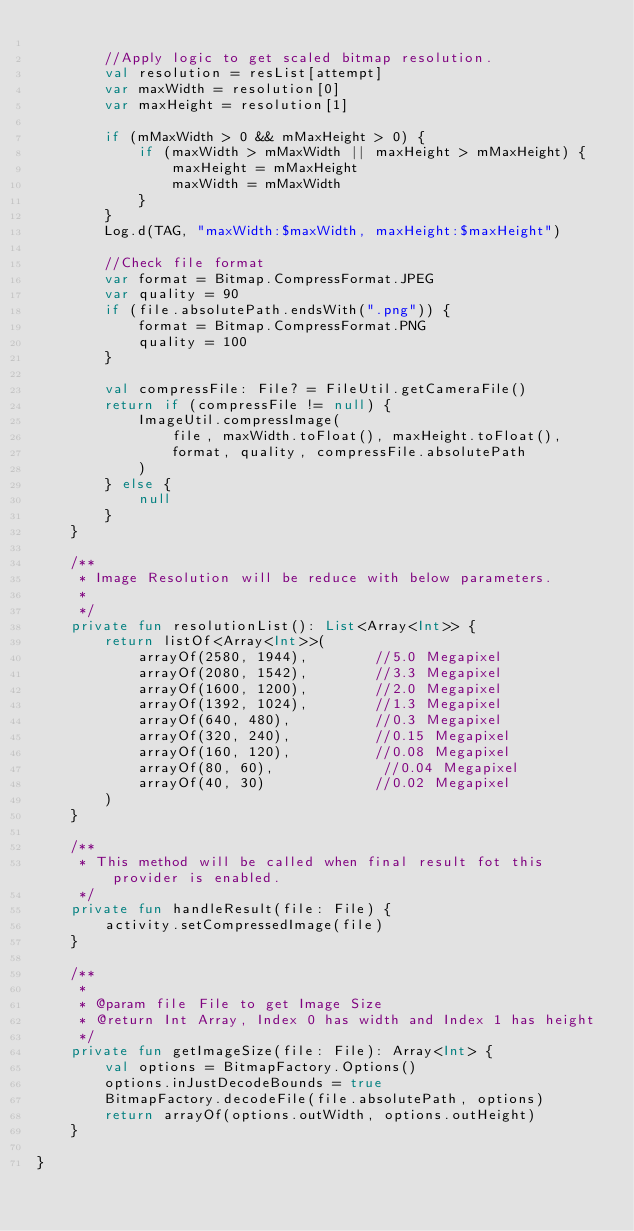<code> <loc_0><loc_0><loc_500><loc_500><_Kotlin_>
        //Apply logic to get scaled bitmap resolution.
        val resolution = resList[attempt]
        var maxWidth = resolution[0]
        var maxHeight = resolution[1]

        if (mMaxWidth > 0 && mMaxHeight > 0) {
            if (maxWidth > mMaxWidth || maxHeight > mMaxHeight) {
                maxHeight = mMaxHeight
                maxWidth = mMaxWidth
            }
        }
        Log.d(TAG, "maxWidth:$maxWidth, maxHeight:$maxHeight")

        //Check file format
        var format = Bitmap.CompressFormat.JPEG
        var quality = 90
        if (file.absolutePath.endsWith(".png")) {
            format = Bitmap.CompressFormat.PNG
            quality = 100
        }

        val compressFile: File? = FileUtil.getCameraFile()
        return if (compressFile != null) {
            ImageUtil.compressImage(
                file, maxWidth.toFloat(), maxHeight.toFloat(),
                format, quality, compressFile.absolutePath
            )
        } else {
            null
        }
    }

    /**
     * Image Resolution will be reduce with below parameters.
     *
     */
    private fun resolutionList(): List<Array<Int>> {
        return listOf<Array<Int>>(
            arrayOf(2580, 1944),        //5.0 Megapixel
            arrayOf(2080, 1542),        //3.3 Megapixel
            arrayOf(1600, 1200),        //2.0 Megapixel
            arrayOf(1392, 1024),        //1.3 Megapixel
            arrayOf(640, 480),          //0.3 Megapixel
            arrayOf(320, 240),          //0.15 Megapixel
            arrayOf(160, 120),          //0.08 Megapixel
            arrayOf(80, 60),             //0.04 Megapixel
            arrayOf(40, 30)             //0.02 Megapixel
        )
    }

    /**
     * This method will be called when final result fot this provider is enabled.
     */
    private fun handleResult(file: File) {
        activity.setCompressedImage(file)
    }

    /**
     *
     * @param file File to get Image Size
     * @return Int Array, Index 0 has width and Index 1 has height
     */
    private fun getImageSize(file: File): Array<Int> {
        val options = BitmapFactory.Options()
        options.inJustDecodeBounds = true
        BitmapFactory.decodeFile(file.absolutePath, options)
        return arrayOf(options.outWidth, options.outHeight)
    }

}</code> 